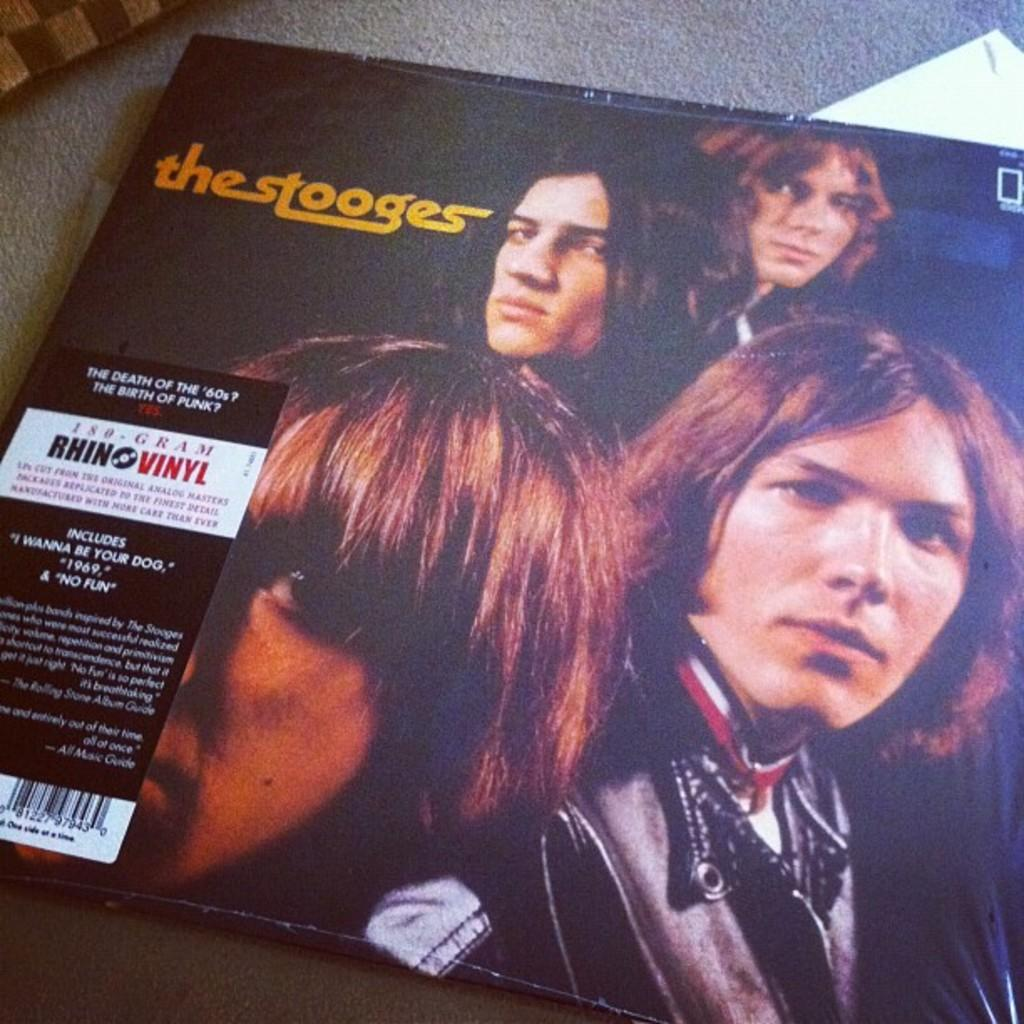What piece of furniture is present in the image? There is a table in the image. What is placed on the table? There is a magazine on the table. What can be seen in the magazine? The magazine has pictures of four persons. What else is featured on the magazine besides the images? There is text written on the magazine. Reasoning: Let's think step by step by step in order to produce the conversation. We start by identifying the main subject in the image, which is the table. Then, we expand the conversation to include the magazine that is placed on the table, focusing on the images and text within the magazine. Each question is designed to elicit a specific detail about the image that is known from the provided facts. Absurd Question/Answer: What type of underwear is visible on the persons in the magazine? There is no underwear visible on the persons in the magazine; the image focuses on the faces of the four individuals. How does the group of four persons move around in the image? The group of four persons does not move around in the image; they are static images within the magazine. 